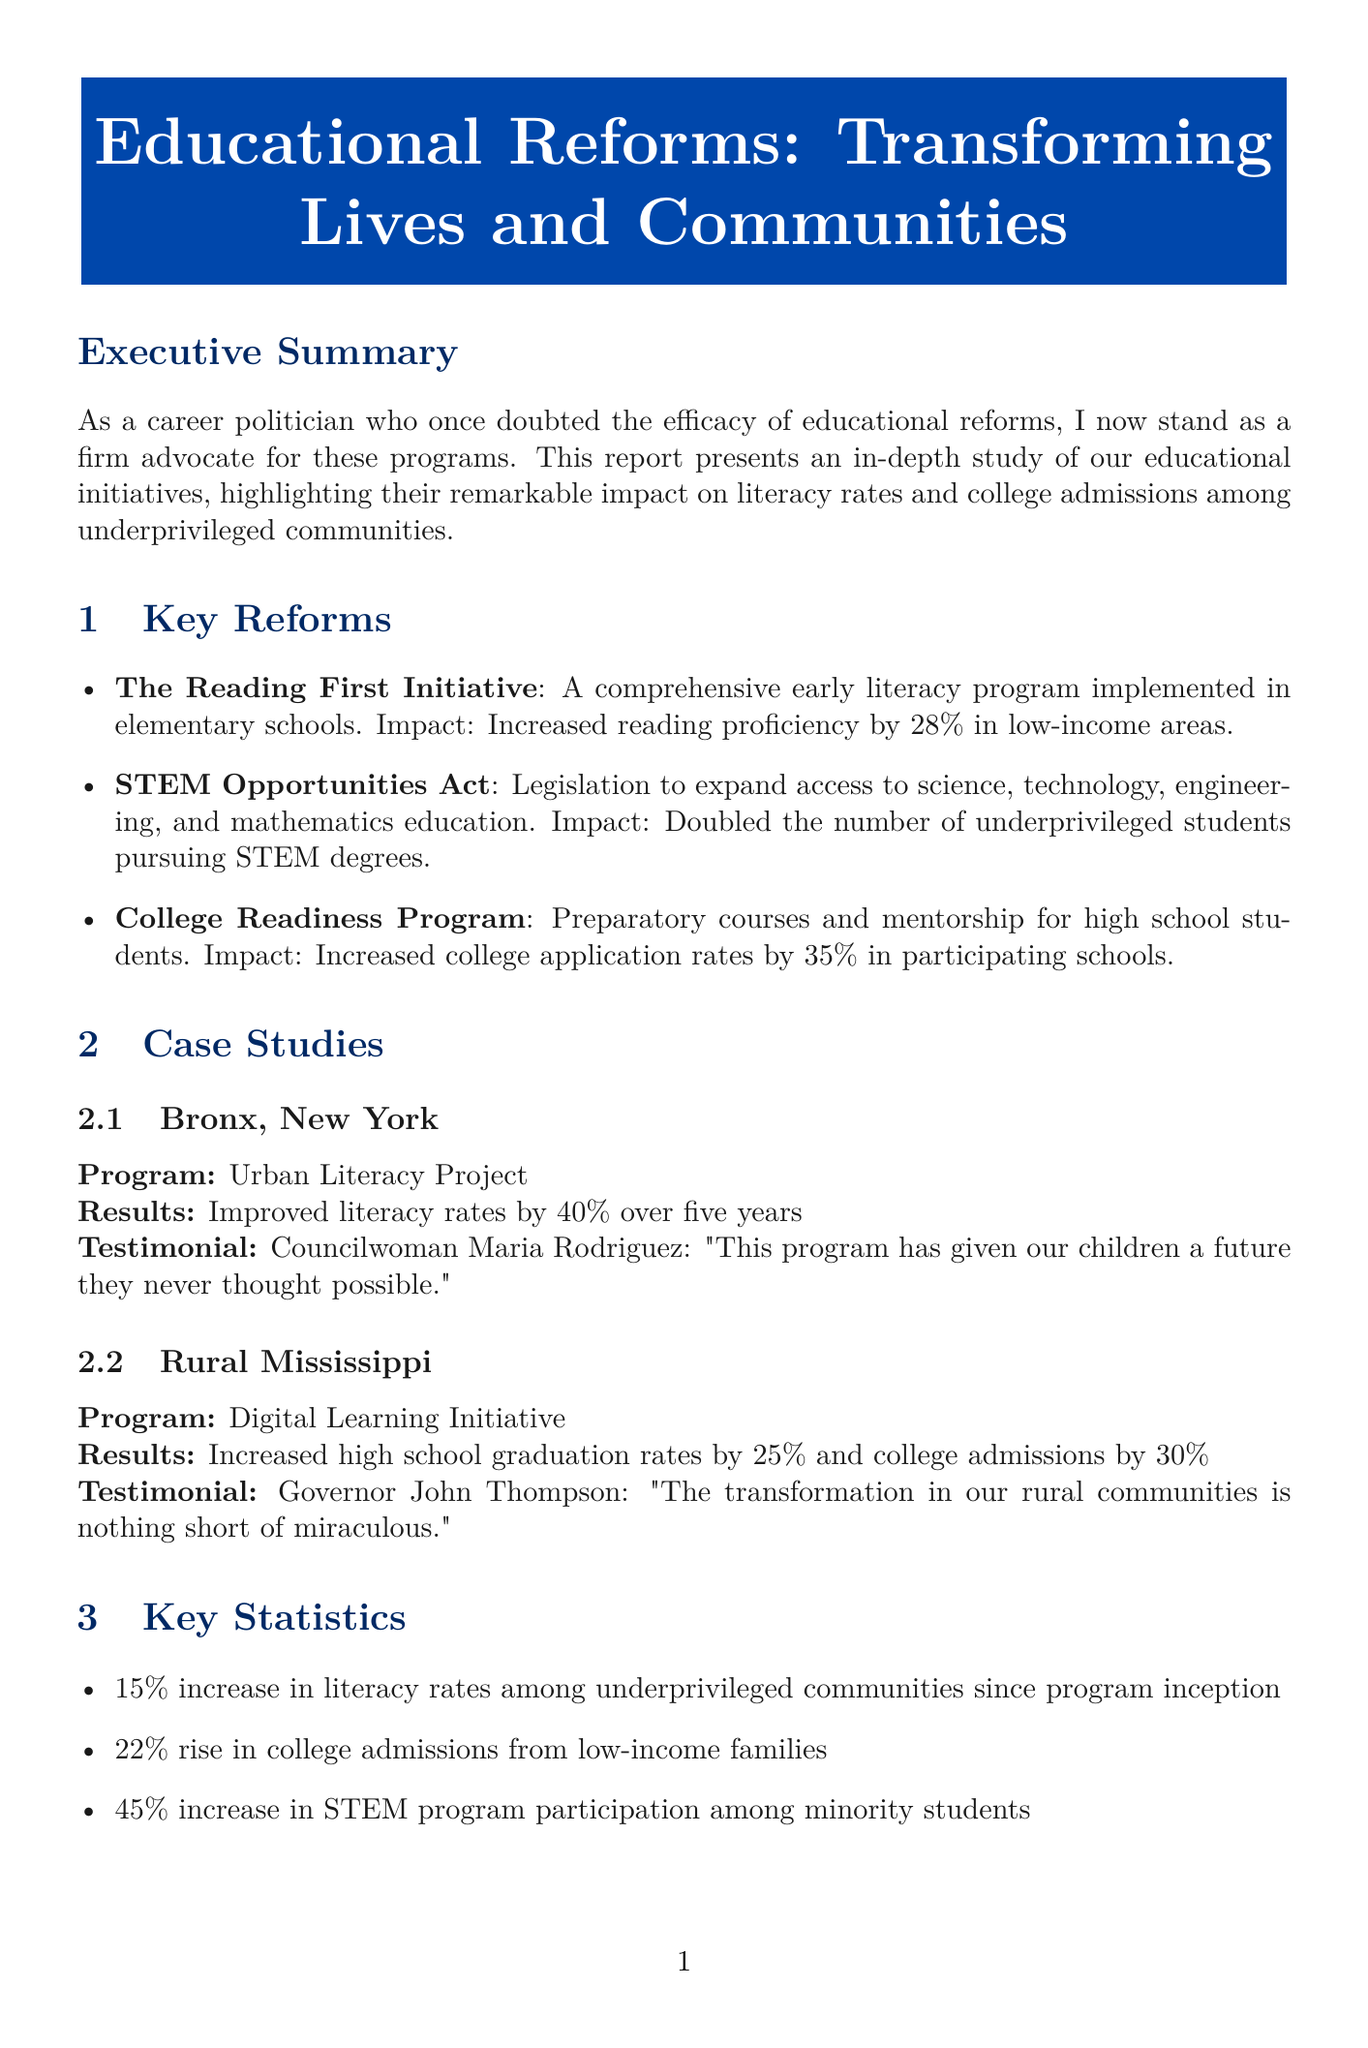What is the title of the report? The title of the report is stated at the beginning of the document.
Answer: Educational Reforms: Transforming Lives and Communities How much has literacy improved nationally? The report mentions a specific percentage increase in literacy rates among underprivileged communities since the inception of the programs.
Answer: 15% increase What percentage of students in low-income areas increased their reading proficiency? This percentage is mentioned as a result of the Reading First Initiative.
Answer: 28% Which program doubled the number of underprivileged students pursuing STEM degrees? The specific program that achieved this is highlighted in the key reforms section.
Answer: STEM Opportunities Act What was the college application rate increase for participating schools in the College Readiness Program? This detail is provided in the impact of the College Readiness Program.
Answer: 35% What is the total investment allocated over five years for educational reforms? The total investment amount is clearly stated in the budget allocation section.
Answer: $5.2 billion What is one future recommendation made in the report? The future recommendations include specific actions that can be taken to expand educational initiatives.
Answer: Expand the Reading First Initiative to middle schools 